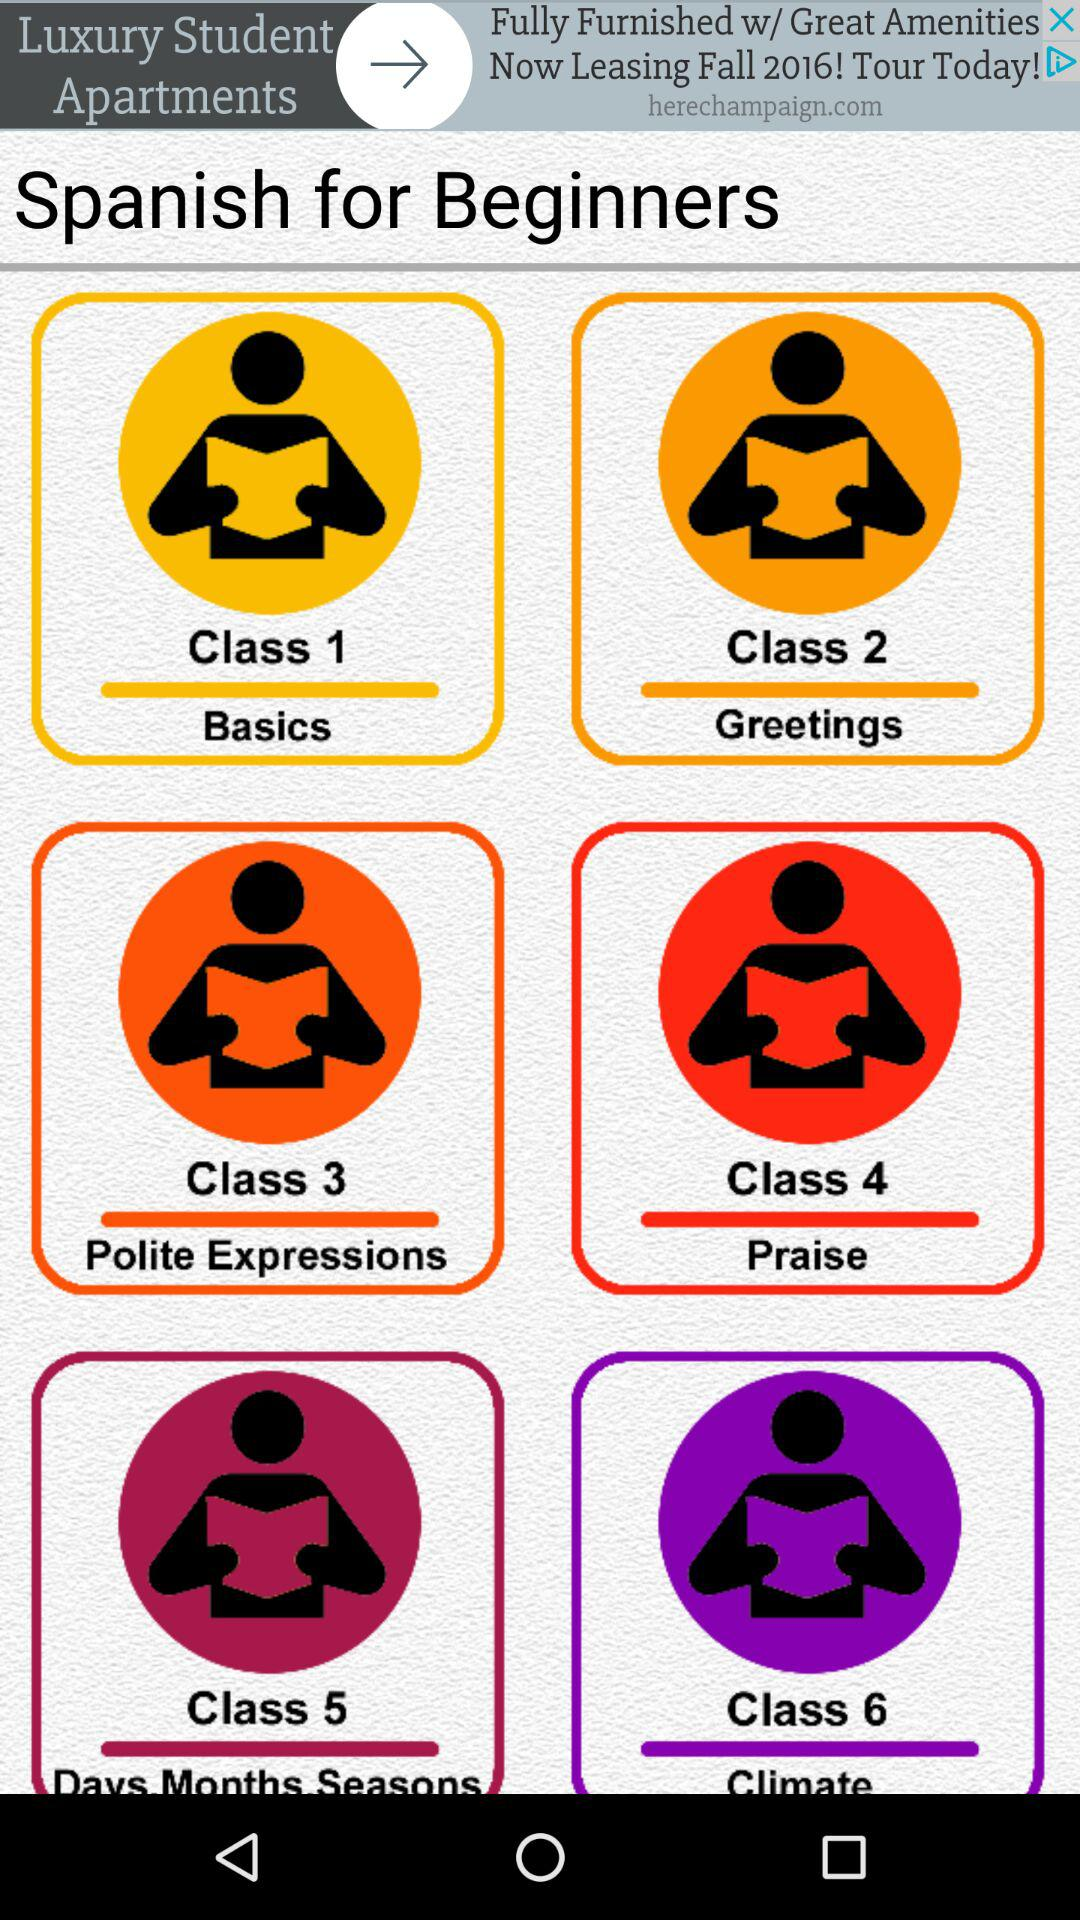How many classes are there in the Spanish for Beginners course?
Answer the question using a single word or phrase. 6 